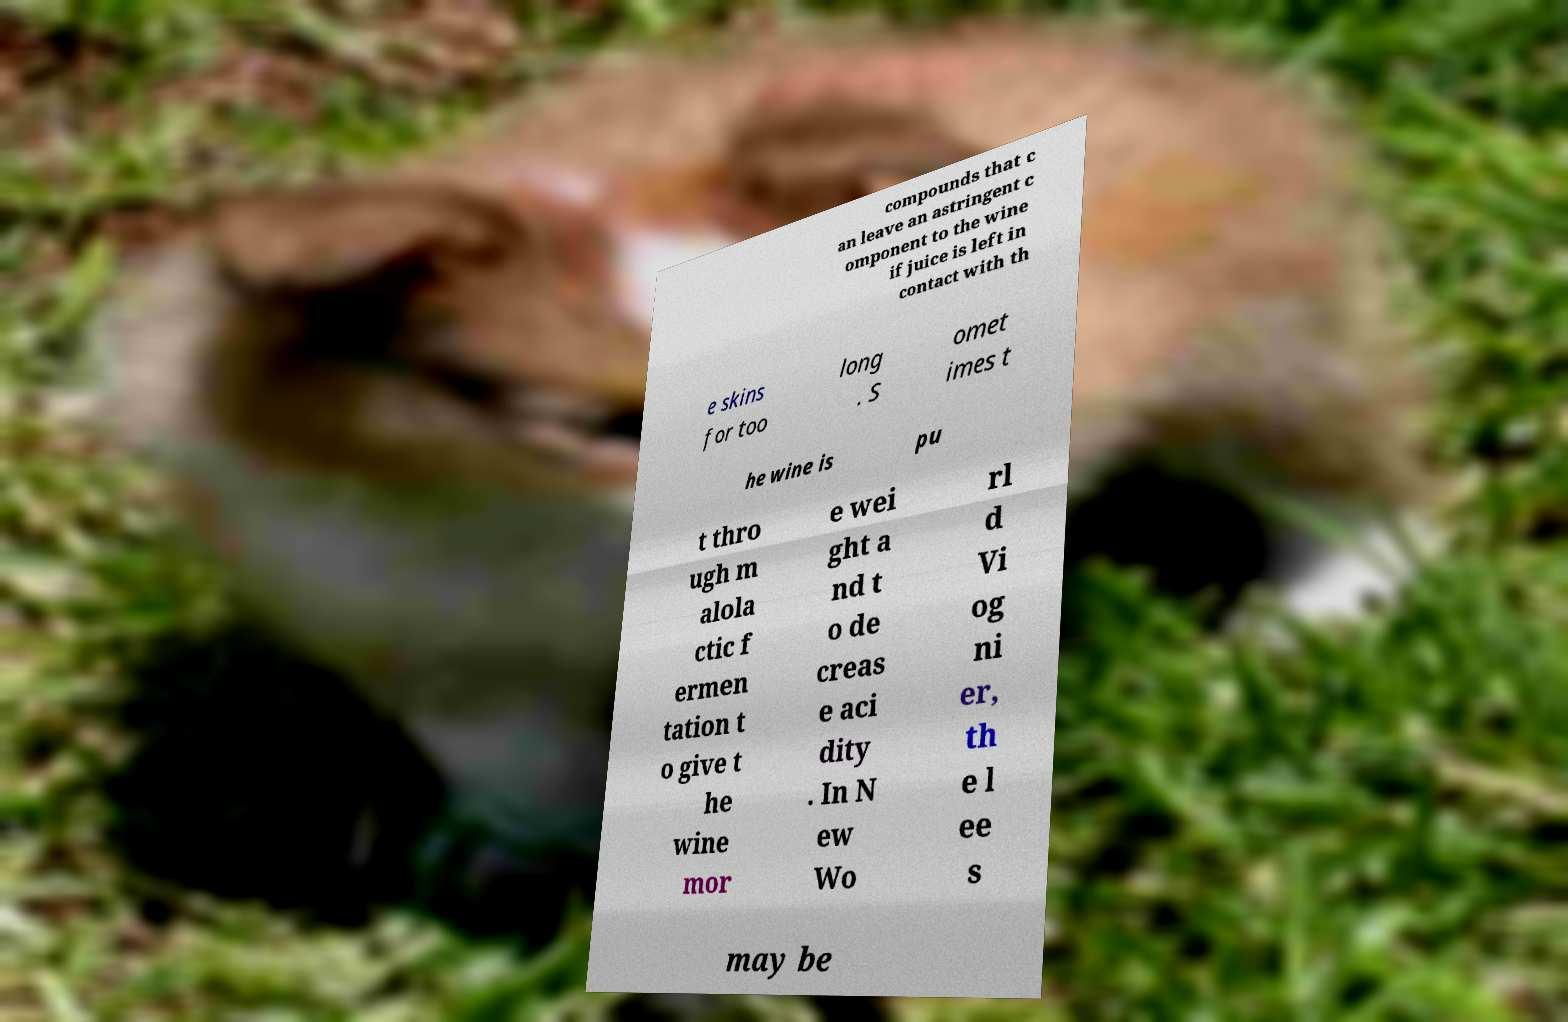Can you accurately transcribe the text from the provided image for me? compounds that c an leave an astringent c omponent to the wine if juice is left in contact with th e skins for too long . S omet imes t he wine is pu t thro ugh m alola ctic f ermen tation t o give t he wine mor e wei ght a nd t o de creas e aci dity . In N ew Wo rl d Vi og ni er, th e l ee s may be 